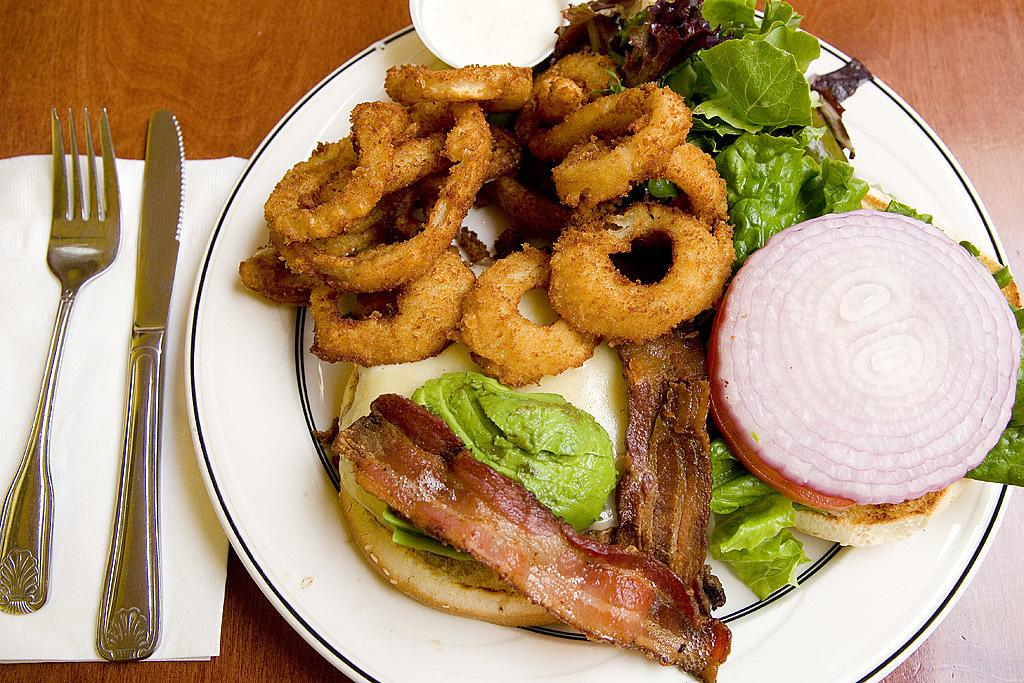What is on the plate in the image? There is a food item on a plate in the image. What utensils are present in the image? A knife and a fork are present in the image. What can be used for wiping or blowing their nose in the image? There is a tissue in the image for wiping or blowing their nose. What is the table made of in the image? The table in the image is made of wood. What type of anger can be seen on the user's face in the image? There is no user or face present in the image; it only shows a food item on a plate, utensils, a tissue, and a wooden table. 